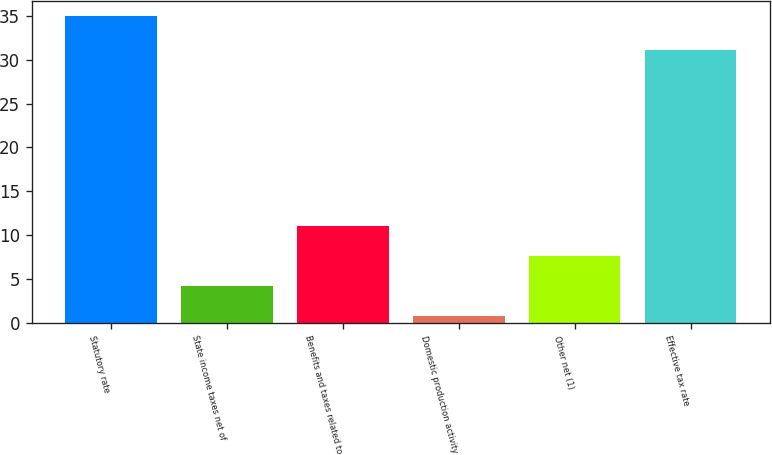<chart> <loc_0><loc_0><loc_500><loc_500><bar_chart><fcel>Statutory rate<fcel>State income taxes net of<fcel>Benefits and taxes related to<fcel>Domestic production activity<fcel>Other net (1)<fcel>Effective tax rate<nl><fcel>35<fcel>4.22<fcel>11.06<fcel>0.8<fcel>7.64<fcel>31.1<nl></chart> 